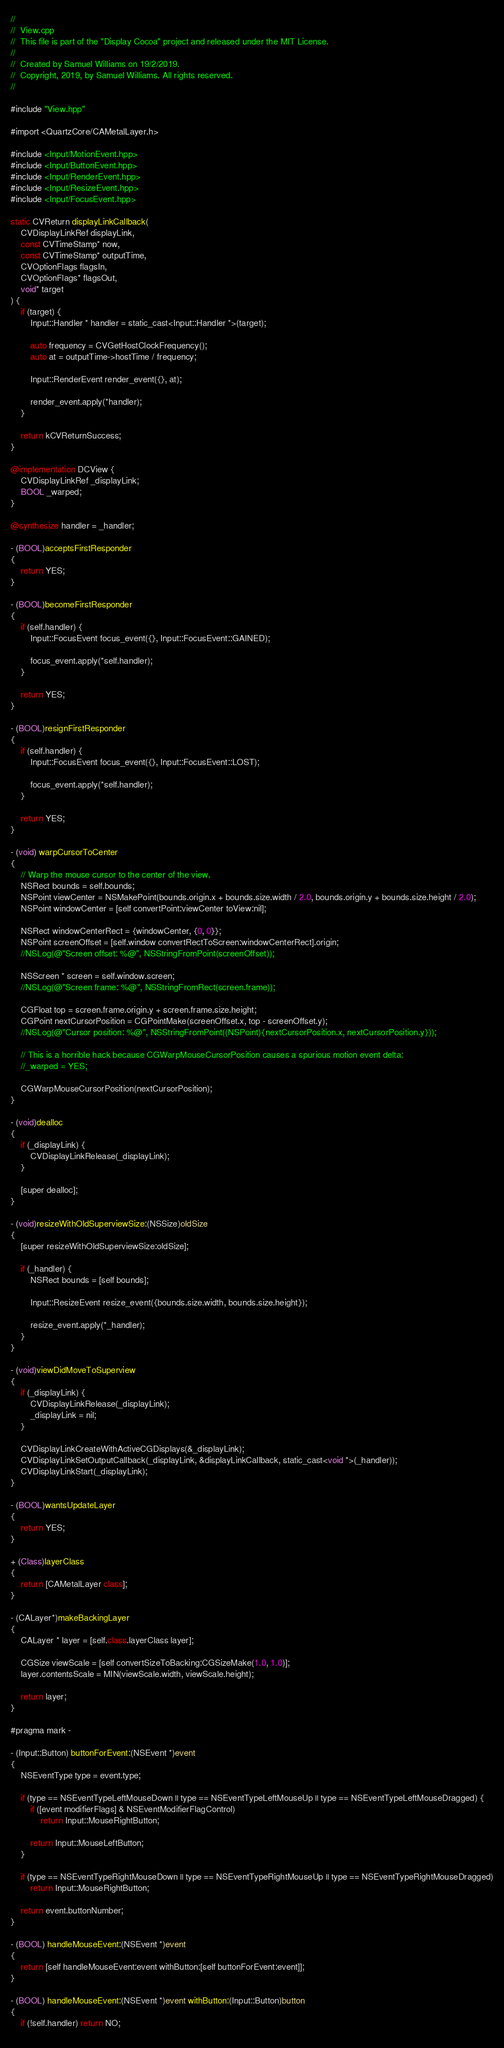Convert code to text. <code><loc_0><loc_0><loc_500><loc_500><_ObjectiveC_>//
//  View.cpp
//  This file is part of the "Display Cocoa" project and released under the MIT License.
//
//  Created by Samuel Williams on 19/2/2019.
//  Copyright, 2019, by Samuel Williams. All rights reserved.
//

#include "View.hpp"

#import <QuartzCore/CAMetalLayer.h>

#include <Input/MotionEvent.hpp>
#include <Input/ButtonEvent.hpp>
#include <Input/RenderEvent.hpp>
#include <Input/ResizeEvent.hpp>
#include <Input/FocusEvent.hpp>

static CVReturn displayLinkCallback(
	CVDisplayLinkRef displayLink,
	const CVTimeStamp* now,
	const CVTimeStamp* outputTime,
	CVOptionFlags flagsIn,
	CVOptionFlags* flagsOut,
	void* target
) {
	if (target) {
		Input::Handler * handler = static_cast<Input::Handler *>(target);
		
		auto frequency = CVGetHostClockFrequency();
		auto at = outputTime->hostTime / frequency;
		
		Input::RenderEvent render_event({}, at);
		
		render_event.apply(*handler);
	}
	
	return kCVReturnSuccess;
}

@implementation DCView {
	CVDisplayLinkRef _displayLink;
	BOOL _warped;
}

@synthesize handler = _handler;

- (BOOL)acceptsFirstResponder
{
	return YES;
}

- (BOOL)becomeFirstResponder
{
	if (self.handler) {
		Input::FocusEvent focus_event({}, Input::FocusEvent::GAINED);
		
		focus_event.apply(*self.handler);
	}
	
	return YES;
}

- (BOOL)resignFirstResponder
{
	if (self.handler) {
		Input::FocusEvent focus_event({}, Input::FocusEvent::LOST);
		
		focus_event.apply(*self.handler);
	}
	
	return YES;
}

- (void) warpCursorToCenter
{
	// Warp the mouse cursor to the center of the view.
	NSRect bounds = self.bounds;
	NSPoint viewCenter = NSMakePoint(bounds.origin.x + bounds.size.width / 2.0, bounds.origin.y + bounds.size.height / 2.0);
	NSPoint windowCenter = [self convertPoint:viewCenter toView:nil];
	
	NSRect windowCenterRect = {windowCenter, {0, 0}};
	NSPoint screenOffset = [self.window convertRectToScreen:windowCenterRect].origin;
	//NSLog(@"Screen offset: %@", NSStringFromPoint(screenOffset));
	
	NSScreen * screen = self.window.screen;
	//NSLog(@"Screen frame: %@", NSStringFromRect(screen.frame));
	
	CGFloat top = screen.frame.origin.y + screen.frame.size.height;
	CGPoint nextCursorPosition = CGPointMake(screenOffset.x, top - screenOffset.y);
	//NSLog(@"Cursor position: %@", NSStringFromPoint((NSPoint){nextCursorPosition.x, nextCursorPosition.y}));
	
	// This is a horrible hack because CGWarpMouseCursorPosition causes a spurious motion event delta:
	//_warped = YES;
	
	CGWarpMouseCursorPosition(nextCursorPosition);
}

- (void)dealloc
{
	if (_displayLink) {
		CVDisplayLinkRelease(_displayLink);
	}
	
	[super dealloc];
}

- (void)resizeWithOldSuperviewSize:(NSSize)oldSize
{
	[super resizeWithOldSuperviewSize:oldSize];
	
	if (_handler) {
		NSRect bounds = [self bounds];
		
		Input::ResizeEvent resize_event({bounds.size.width, bounds.size.height});
		
		resize_event.apply(*_handler);
	}
}

- (void)viewDidMoveToSuperview
{
	if (_displayLink) {
		CVDisplayLinkRelease(_displayLink);
		_displayLink = nil;
	}
	
	CVDisplayLinkCreateWithActiveCGDisplays(&_displayLink);
	CVDisplayLinkSetOutputCallback(_displayLink, &displayLinkCallback, static_cast<void *>(_handler));
	CVDisplayLinkStart(_displayLink);
}

- (BOOL)wantsUpdateLayer
{
	return YES;
}

+ (Class)layerClass
{
	return [CAMetalLayer class];
}

- (CALayer*)makeBackingLayer
{
	CALayer * layer = [self.class.layerClass layer];
	
	CGSize viewScale = [self convertSizeToBacking:CGSizeMake(1.0, 1.0)];
	layer.contentsScale = MIN(viewScale.width, viewScale.height);
	
	return layer;
}

#pragma mark -

- (Input::Button) buttonForEvent:(NSEvent *)event
{
	NSEventType type = event.type;
	
	if (type == NSEventTypeLeftMouseDown || type == NSEventTypeLeftMouseUp || type == NSEventTypeLeftMouseDragged) {
		if ([event modifierFlags] & NSEventModifierFlagControl)
			return Input::MouseRightButton;
		
		return Input::MouseLeftButton;
	}
	
	if (type == NSEventTypeRightMouseDown || type == NSEventTypeRightMouseUp || type == NSEventTypeRightMouseDragged)
		return Input::MouseRightButton;
	
	return event.buttonNumber;
}

- (BOOL) handleMouseEvent:(NSEvent *)event
{
	return [self handleMouseEvent:event withButton:[self buttonForEvent:event]];
}

- (BOOL) handleMouseEvent:(NSEvent *)event withButton:(Input::Button)button
{
	if (!self.handler) return NO;
	</code> 